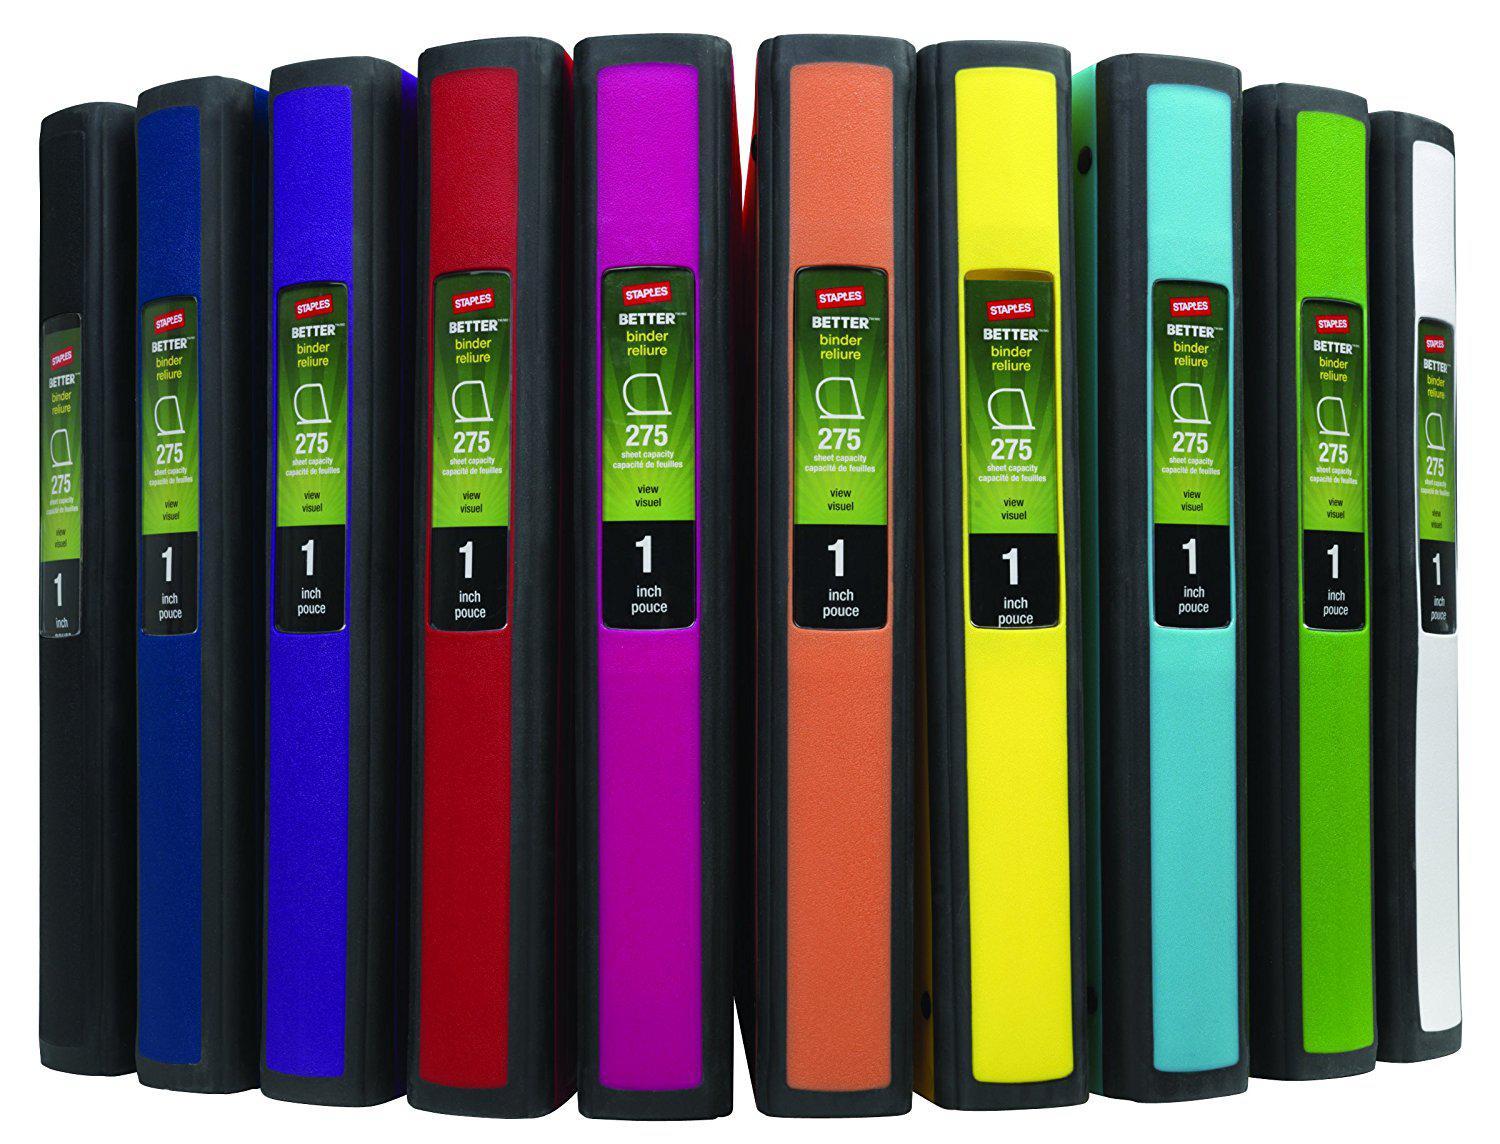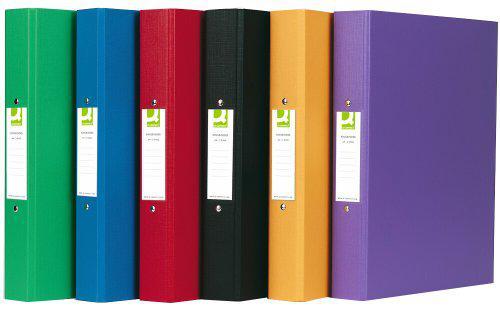The first image is the image on the left, the second image is the image on the right. Evaluate the accuracy of this statement regarding the images: "In one of the pictures, the white binder is between the black and red binders.". Is it true? Answer yes or no. No. The first image is the image on the left, the second image is the image on the right. Considering the images on both sides, is "One image shows different colored binders displayed at some angle, instead of curved or straight ahead." valid? Answer yes or no. Yes. 